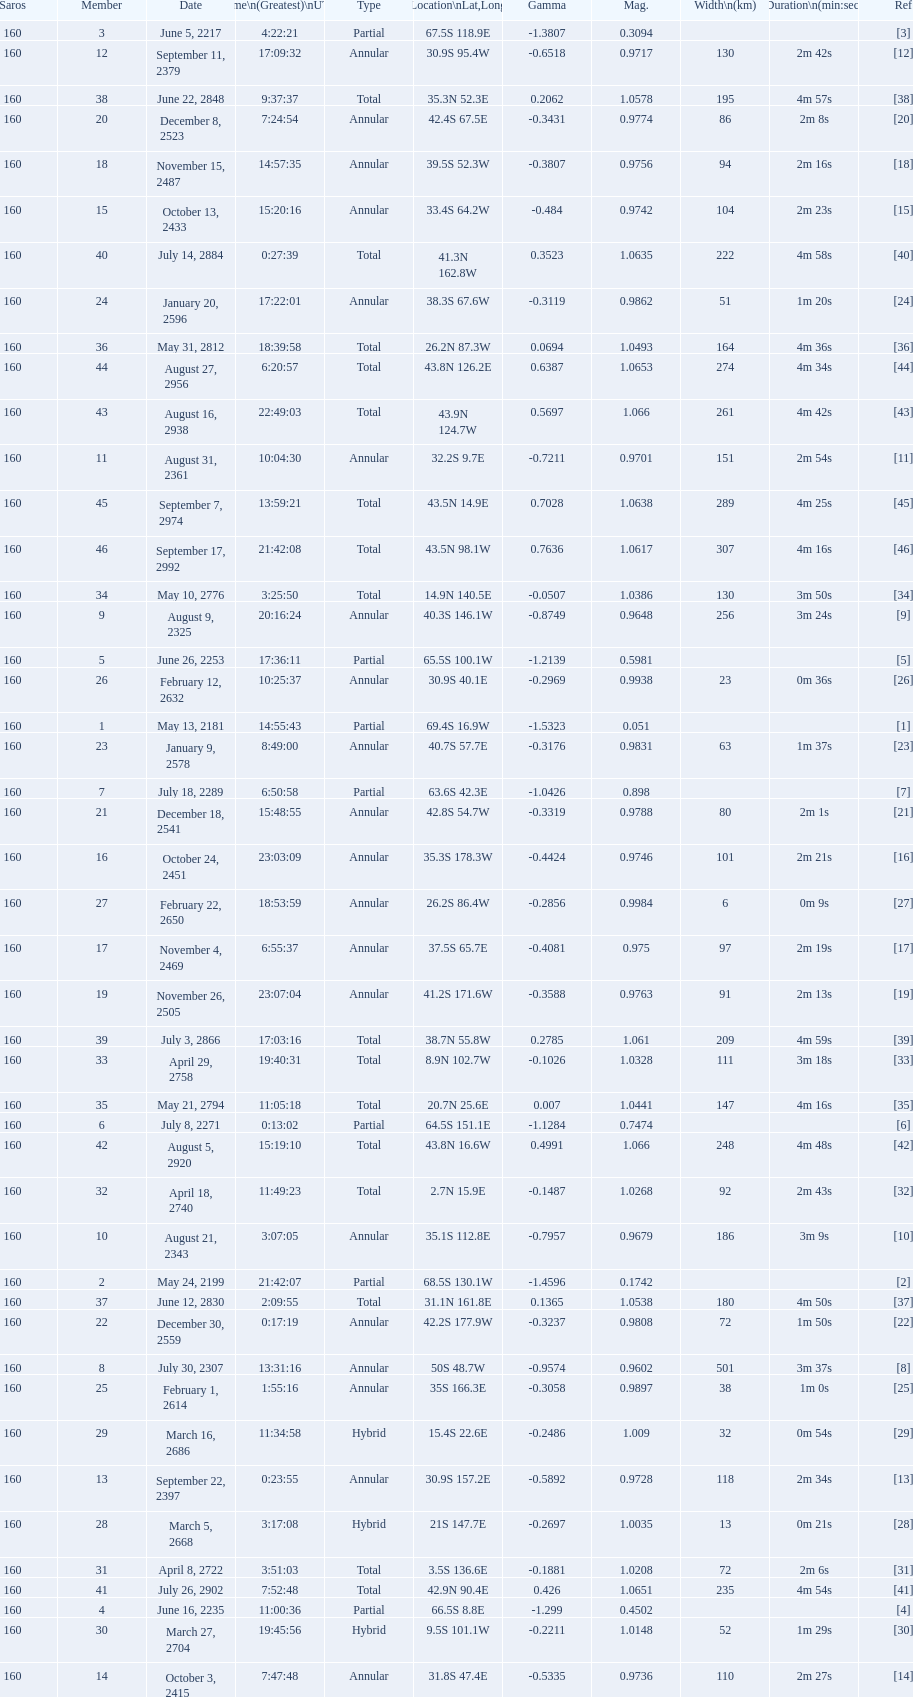Before october 3, 2415, when was the most recent saros? 7:47:48. 